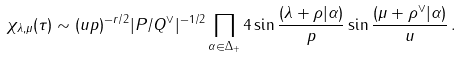<formula> <loc_0><loc_0><loc_500><loc_500>\chi _ { \lambda , \mu } ( \tau ) \sim ( u p ) ^ { - r / 2 } | P / Q ^ { \vee } | ^ { - 1 / 2 } \prod _ { \alpha \in \Delta _ { + } } 4 \sin \frac { ( \lambda + \rho | \alpha ) } { p } \sin \frac { ( \mu + \rho ^ { \vee } | \alpha ) } { u } \, .</formula> 